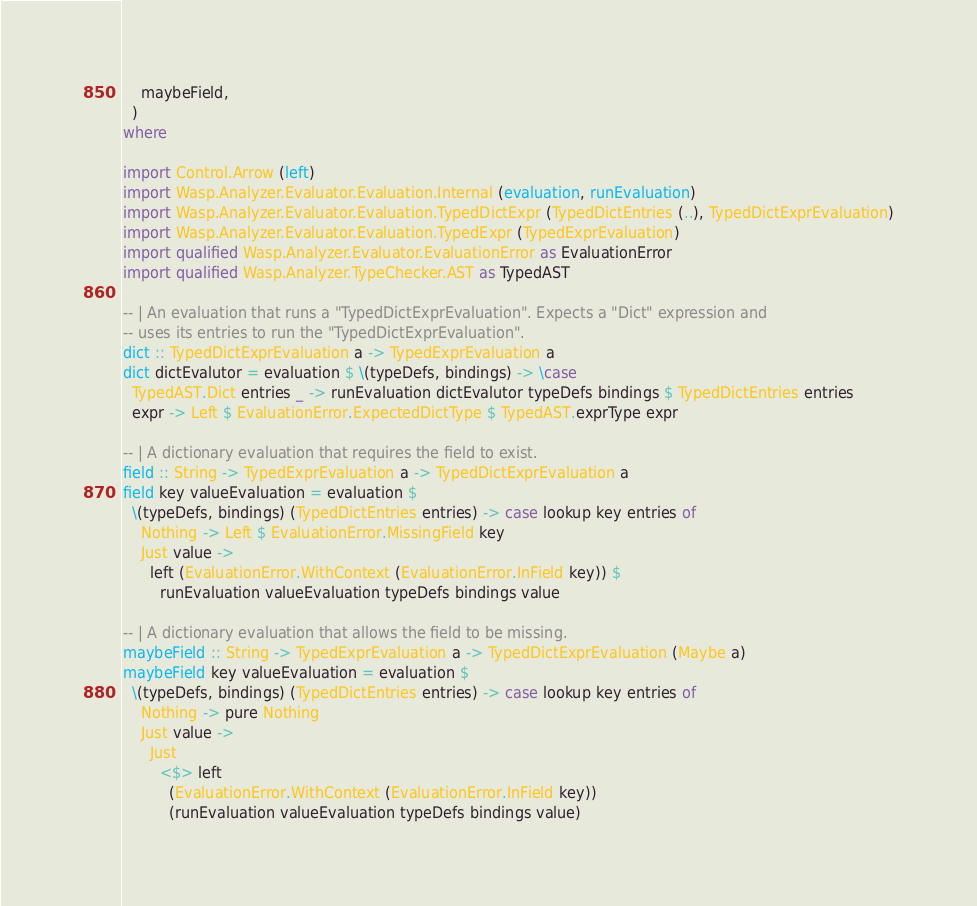Convert code to text. <code><loc_0><loc_0><loc_500><loc_500><_Haskell_>    maybeField,
  )
where

import Control.Arrow (left)
import Wasp.Analyzer.Evaluator.Evaluation.Internal (evaluation, runEvaluation)
import Wasp.Analyzer.Evaluator.Evaluation.TypedDictExpr (TypedDictEntries (..), TypedDictExprEvaluation)
import Wasp.Analyzer.Evaluator.Evaluation.TypedExpr (TypedExprEvaluation)
import qualified Wasp.Analyzer.Evaluator.EvaluationError as EvaluationError
import qualified Wasp.Analyzer.TypeChecker.AST as TypedAST

-- | An evaluation that runs a "TypedDictExprEvaluation". Expects a "Dict" expression and
-- uses its entries to run the "TypedDictExprEvaluation".
dict :: TypedDictExprEvaluation a -> TypedExprEvaluation a
dict dictEvalutor = evaluation $ \(typeDefs, bindings) -> \case
  TypedAST.Dict entries _ -> runEvaluation dictEvalutor typeDefs bindings $ TypedDictEntries entries
  expr -> Left $ EvaluationError.ExpectedDictType $ TypedAST.exprType expr

-- | A dictionary evaluation that requires the field to exist.
field :: String -> TypedExprEvaluation a -> TypedDictExprEvaluation a
field key valueEvaluation = evaluation $
  \(typeDefs, bindings) (TypedDictEntries entries) -> case lookup key entries of
    Nothing -> Left $ EvaluationError.MissingField key
    Just value ->
      left (EvaluationError.WithContext (EvaluationError.InField key)) $
        runEvaluation valueEvaluation typeDefs bindings value

-- | A dictionary evaluation that allows the field to be missing.
maybeField :: String -> TypedExprEvaluation a -> TypedDictExprEvaluation (Maybe a)
maybeField key valueEvaluation = evaluation $
  \(typeDefs, bindings) (TypedDictEntries entries) -> case lookup key entries of
    Nothing -> pure Nothing
    Just value ->
      Just
        <$> left
          (EvaluationError.WithContext (EvaluationError.InField key))
          (runEvaluation valueEvaluation typeDefs bindings value)
</code> 